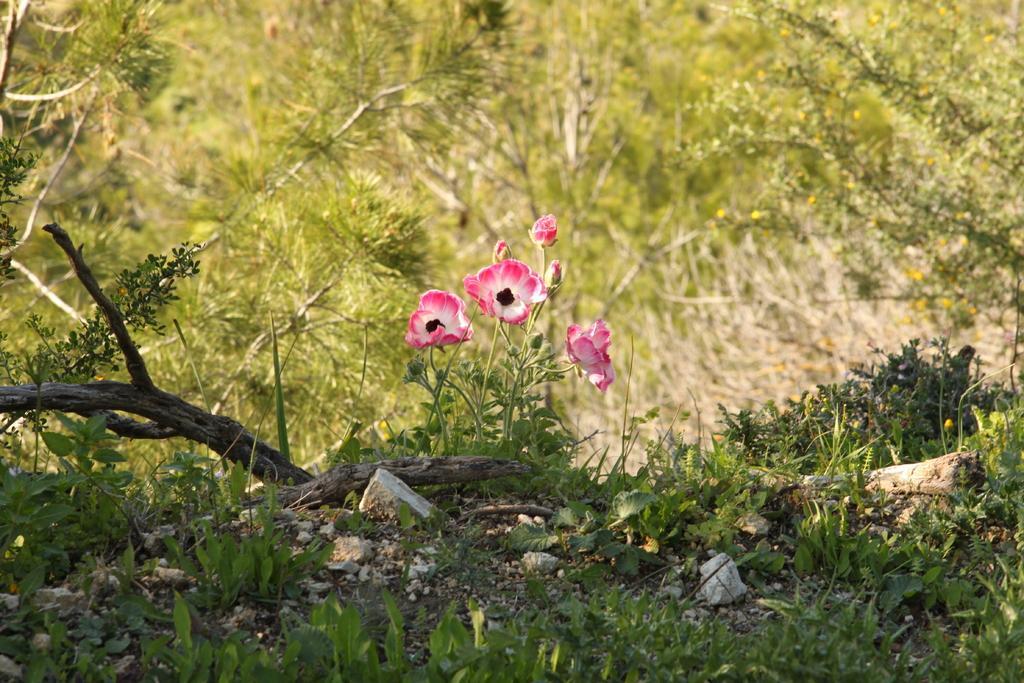Could you give a brief overview of what you see in this image? In this image, we can see some plants. There are flowers in the middle of the image. 